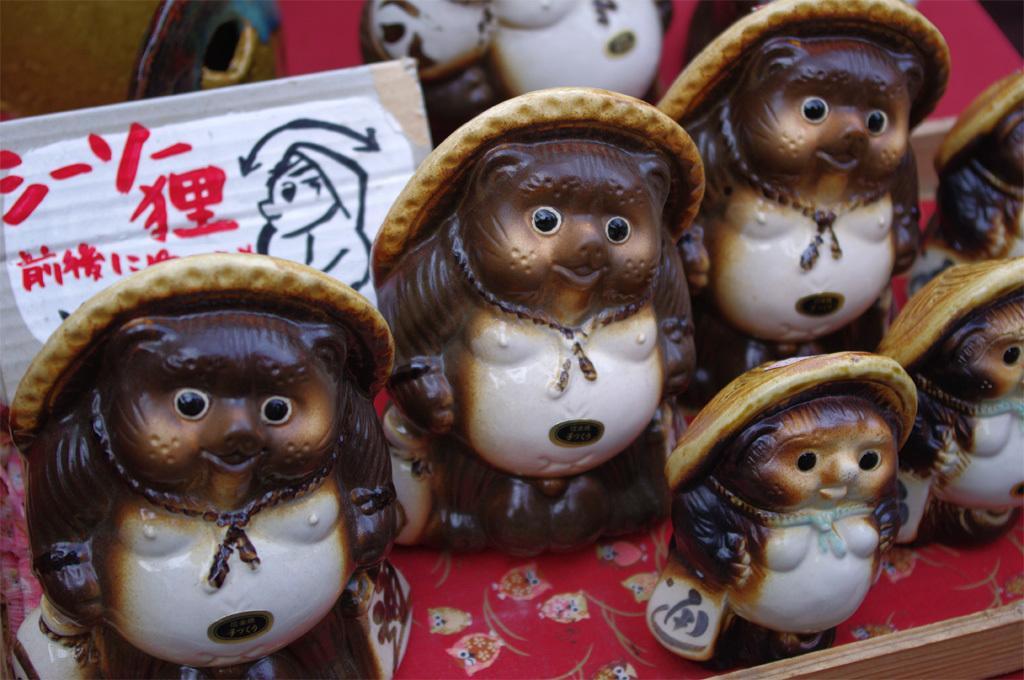Please provide a concise description of this image. In the image there are ceramic toys. 